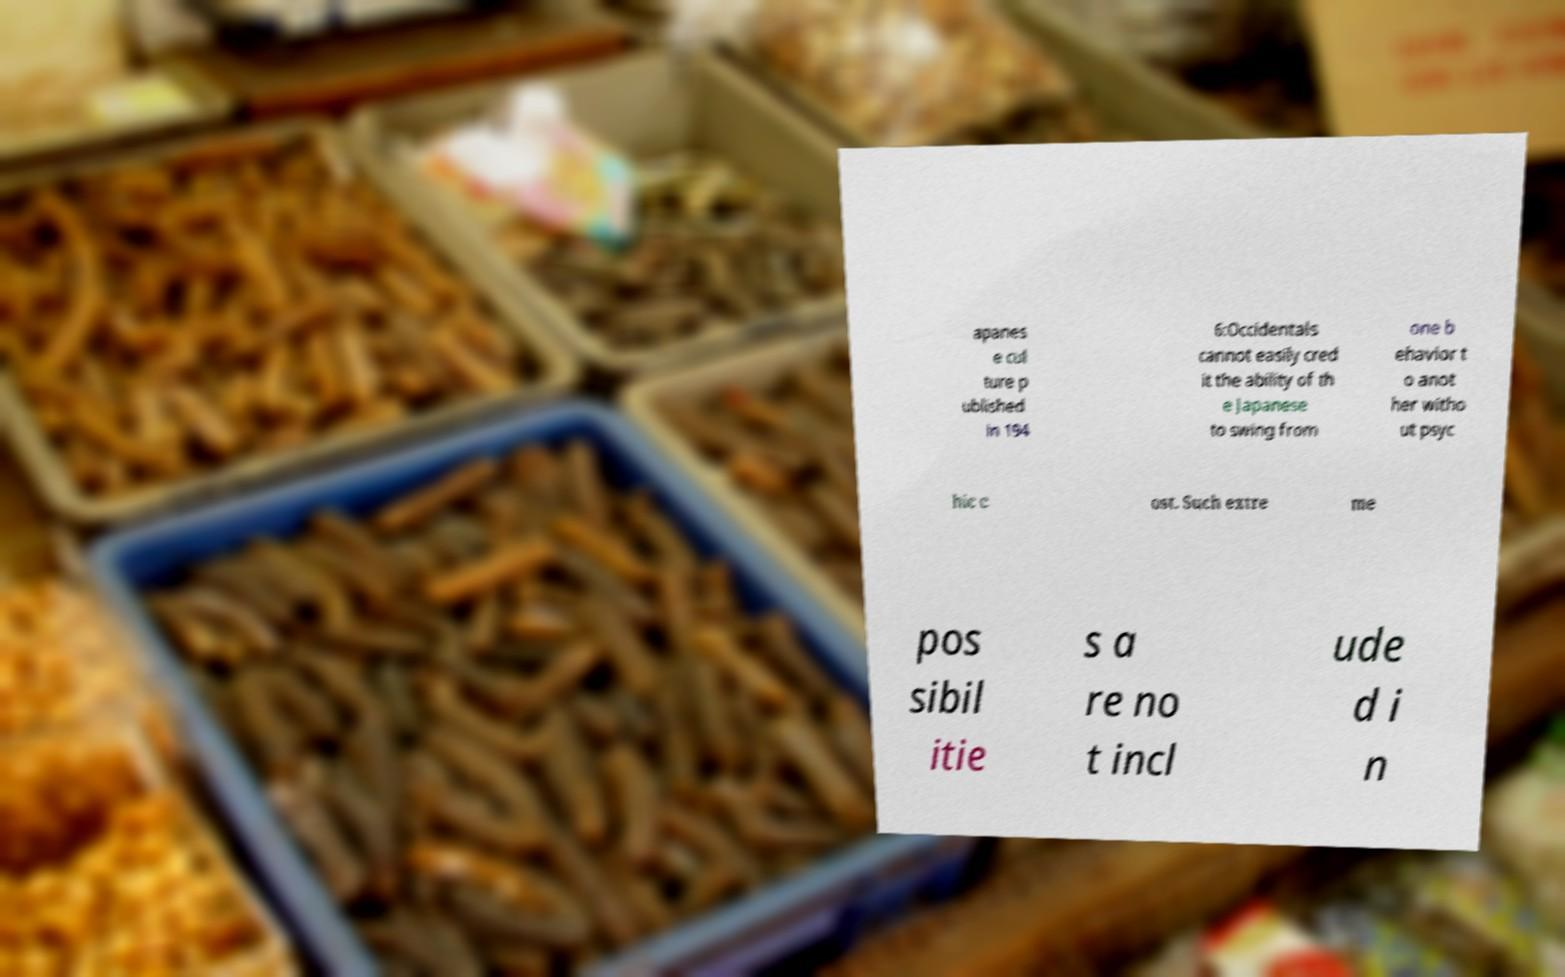Please identify and transcribe the text found in this image. apanes e cul ture p ublished in 194 6:Occidentals cannot easily cred it the ability of th e Japanese to swing from one b ehavior t o anot her witho ut psyc hic c ost. Such extre me pos sibil itie s a re no t incl ude d i n 